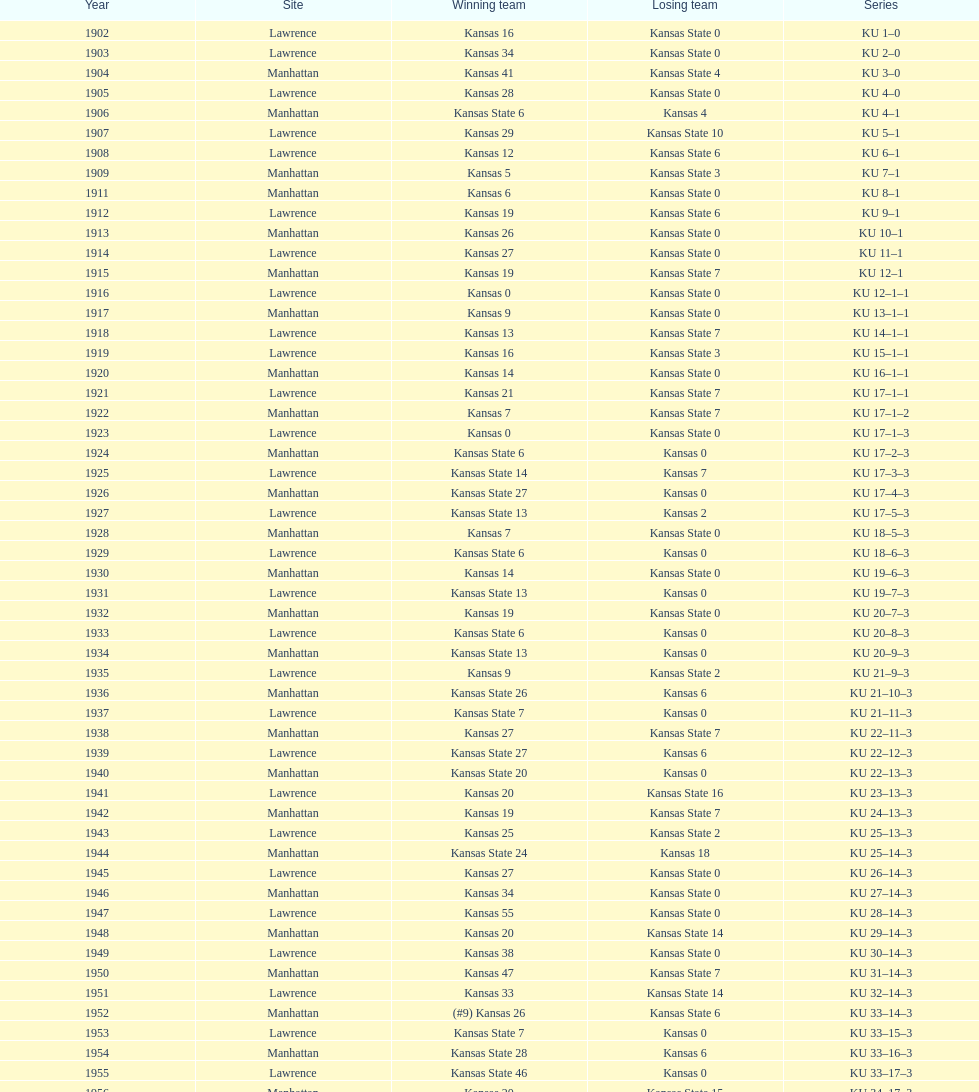What is the total number of games played? 66. Could you help me parse every detail presented in this table? {'header': ['Year', 'Site', 'Winning team', 'Losing team', 'Series'], 'rows': [['1902', 'Lawrence', 'Kansas 16', 'Kansas State 0', 'KU 1–0'], ['1903', 'Lawrence', 'Kansas 34', 'Kansas State 0', 'KU 2–0'], ['1904', 'Manhattan', 'Kansas 41', 'Kansas State 4', 'KU 3–0'], ['1905', 'Lawrence', 'Kansas 28', 'Kansas State 0', 'KU 4–0'], ['1906', 'Manhattan', 'Kansas State 6', 'Kansas 4', 'KU 4–1'], ['1907', 'Lawrence', 'Kansas 29', 'Kansas State 10', 'KU 5–1'], ['1908', 'Lawrence', 'Kansas 12', 'Kansas State 6', 'KU 6–1'], ['1909', 'Manhattan', 'Kansas 5', 'Kansas State 3', 'KU 7–1'], ['1911', 'Manhattan', 'Kansas 6', 'Kansas State 0', 'KU 8–1'], ['1912', 'Lawrence', 'Kansas 19', 'Kansas State 6', 'KU 9–1'], ['1913', 'Manhattan', 'Kansas 26', 'Kansas State 0', 'KU 10–1'], ['1914', 'Lawrence', 'Kansas 27', 'Kansas State 0', 'KU 11–1'], ['1915', 'Manhattan', 'Kansas 19', 'Kansas State 7', 'KU 12–1'], ['1916', 'Lawrence', 'Kansas 0', 'Kansas State 0', 'KU 12–1–1'], ['1917', 'Manhattan', 'Kansas 9', 'Kansas State 0', 'KU 13–1–1'], ['1918', 'Lawrence', 'Kansas 13', 'Kansas State 7', 'KU 14–1–1'], ['1919', 'Lawrence', 'Kansas 16', 'Kansas State 3', 'KU 15–1–1'], ['1920', 'Manhattan', 'Kansas 14', 'Kansas State 0', 'KU 16–1–1'], ['1921', 'Lawrence', 'Kansas 21', 'Kansas State 7', 'KU 17–1–1'], ['1922', 'Manhattan', 'Kansas 7', 'Kansas State 7', 'KU 17–1–2'], ['1923', 'Lawrence', 'Kansas 0', 'Kansas State 0', 'KU 17–1–3'], ['1924', 'Manhattan', 'Kansas State 6', 'Kansas 0', 'KU 17–2–3'], ['1925', 'Lawrence', 'Kansas State 14', 'Kansas 7', 'KU 17–3–3'], ['1926', 'Manhattan', 'Kansas State 27', 'Kansas 0', 'KU 17–4–3'], ['1927', 'Lawrence', 'Kansas State 13', 'Kansas 2', 'KU 17–5–3'], ['1928', 'Manhattan', 'Kansas 7', 'Kansas State 0', 'KU 18–5–3'], ['1929', 'Lawrence', 'Kansas State 6', 'Kansas 0', 'KU 18–6–3'], ['1930', 'Manhattan', 'Kansas 14', 'Kansas State 0', 'KU 19–6–3'], ['1931', 'Lawrence', 'Kansas State 13', 'Kansas 0', 'KU 19–7–3'], ['1932', 'Manhattan', 'Kansas 19', 'Kansas State 0', 'KU 20–7–3'], ['1933', 'Lawrence', 'Kansas State 6', 'Kansas 0', 'KU 20–8–3'], ['1934', 'Manhattan', 'Kansas State 13', 'Kansas 0', 'KU 20–9–3'], ['1935', 'Lawrence', 'Kansas 9', 'Kansas State 2', 'KU 21–9–3'], ['1936', 'Manhattan', 'Kansas State 26', 'Kansas 6', 'KU 21–10–3'], ['1937', 'Lawrence', 'Kansas State 7', 'Kansas 0', 'KU 21–11–3'], ['1938', 'Manhattan', 'Kansas 27', 'Kansas State 7', 'KU 22–11–3'], ['1939', 'Lawrence', 'Kansas State 27', 'Kansas 6', 'KU 22–12–3'], ['1940', 'Manhattan', 'Kansas State 20', 'Kansas 0', 'KU 22–13–3'], ['1941', 'Lawrence', 'Kansas 20', 'Kansas State 16', 'KU 23–13–3'], ['1942', 'Manhattan', 'Kansas 19', 'Kansas State 7', 'KU 24–13–3'], ['1943', 'Lawrence', 'Kansas 25', 'Kansas State 2', 'KU 25–13–3'], ['1944', 'Manhattan', 'Kansas State 24', 'Kansas 18', 'KU 25–14–3'], ['1945', 'Lawrence', 'Kansas 27', 'Kansas State 0', 'KU 26–14–3'], ['1946', 'Manhattan', 'Kansas 34', 'Kansas State 0', 'KU 27–14–3'], ['1947', 'Lawrence', 'Kansas 55', 'Kansas State 0', 'KU 28–14–3'], ['1948', 'Manhattan', 'Kansas 20', 'Kansas State 14', 'KU 29–14–3'], ['1949', 'Lawrence', 'Kansas 38', 'Kansas State 0', 'KU 30–14–3'], ['1950', 'Manhattan', 'Kansas 47', 'Kansas State 7', 'KU 31–14–3'], ['1951', 'Lawrence', 'Kansas 33', 'Kansas State 14', 'KU 32–14–3'], ['1952', 'Manhattan', '(#9) Kansas 26', 'Kansas State 6', 'KU 33–14–3'], ['1953', 'Lawrence', 'Kansas State 7', 'Kansas 0', 'KU 33–15–3'], ['1954', 'Manhattan', 'Kansas State 28', 'Kansas 6', 'KU 33–16–3'], ['1955', 'Lawrence', 'Kansas State 46', 'Kansas 0', 'KU 33–17–3'], ['1956', 'Manhattan', 'Kansas 20', 'Kansas State 15', 'KU 34–17–3'], ['1957', 'Lawrence', 'Kansas 13', 'Kansas State 7', 'KU 35–17–3'], ['1958', 'Manhattan', 'Kansas 21', 'Kansas State 12', 'KU 36–17–3'], ['1959', 'Lawrence', 'Kansas 33', 'Kansas State 14', 'KU 37–17–3'], ['1960', 'Manhattan', 'Kansas 41', 'Kansas State 0', 'KU 38–17–3'], ['1961', 'Lawrence', 'Kansas 34', 'Kansas State 0', 'KU 39–17–3'], ['1962', 'Manhattan', 'Kansas 38', 'Kansas State 0', 'KU 40–17–3'], ['1963', 'Lawrence', 'Kansas 34', 'Kansas State 0', 'KU 41–17–3'], ['1964', 'Manhattan', 'Kansas 7', 'Kansas State 0', 'KU 42–17–3'], ['1965', 'Lawrence', 'Kansas 34', 'Kansas State 0', 'KU 43–17–3'], ['1966', 'Manhattan', 'Kansas 3', 'Kansas State 3', 'KU 43–17–4'], ['1967', 'Lawrence', 'Kansas 17', 'Kansas State 16', 'KU 44–17–4'], ['1968', 'Manhattan', '(#7) Kansas 38', 'Kansas State 29', 'KU 45–17–4']]} 